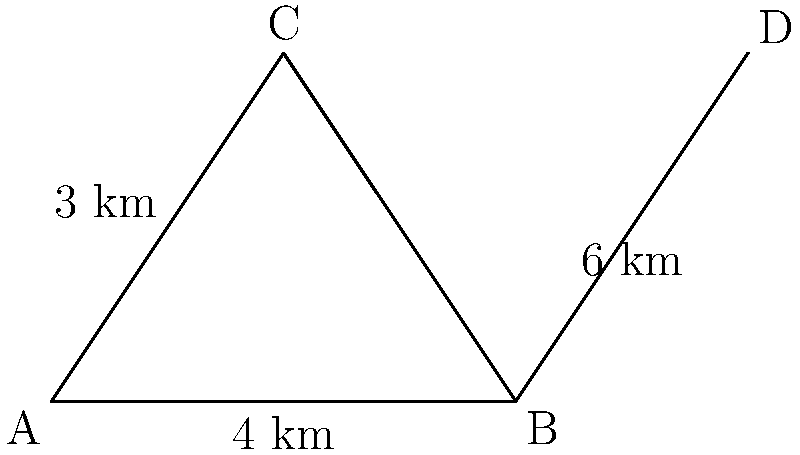In a scaled diagram of a school district, triangle ABC represents the locations of three schools. Point D represents a new housing development. If AB is 4 km, BC is 6 km, and the height of the triangle is 3 km, what is the actual distance between School B and the new housing development (BD)? To solve this problem, we'll use the properties of congruent triangles:

1) First, we need to recognize that triangles ABC and ABD are similar, as they share the same height and base AB.

2) In triangle ABC:
   Base (AB) = 4 km
   Height = 3 km
   Hypotenuse (BC) = 6 km

3) We can find the ratio of similarity by comparing the bases:
   $\frac{BD}{BC} = \frac{AB + BD}{AB} = \frac{x + 4}{4}$, where x is the length of BD

4) Since the triangles are similar, this ratio will be the same for all corresponding sides. So:
   $\frac{x + 4}{4} = \frac{6}{4} = 1.5$

5) Solving for x:
   $x + 4 = 1.5 * 4 = 6$
   $x = 6 - 4 = 2$

Therefore, the distance BD is 2 km.

This problem demonstrates how scaled diagrams and congruent triangles can be used to calculate real-world distances, which is crucial for urban planning and resource allocation in education.
Answer: 2 km 